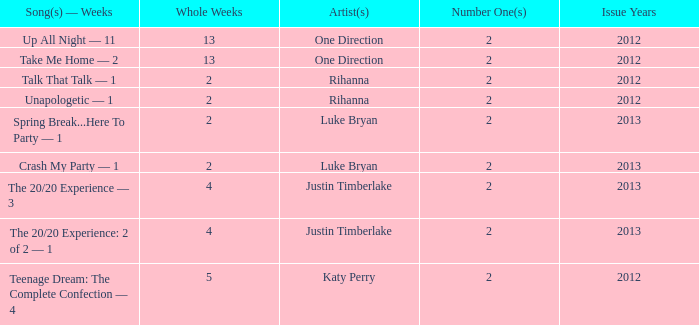What is the title of every song, and how many weeks was each song at #1 for One Direction? Up All Night — 11, Take Me Home — 2. 